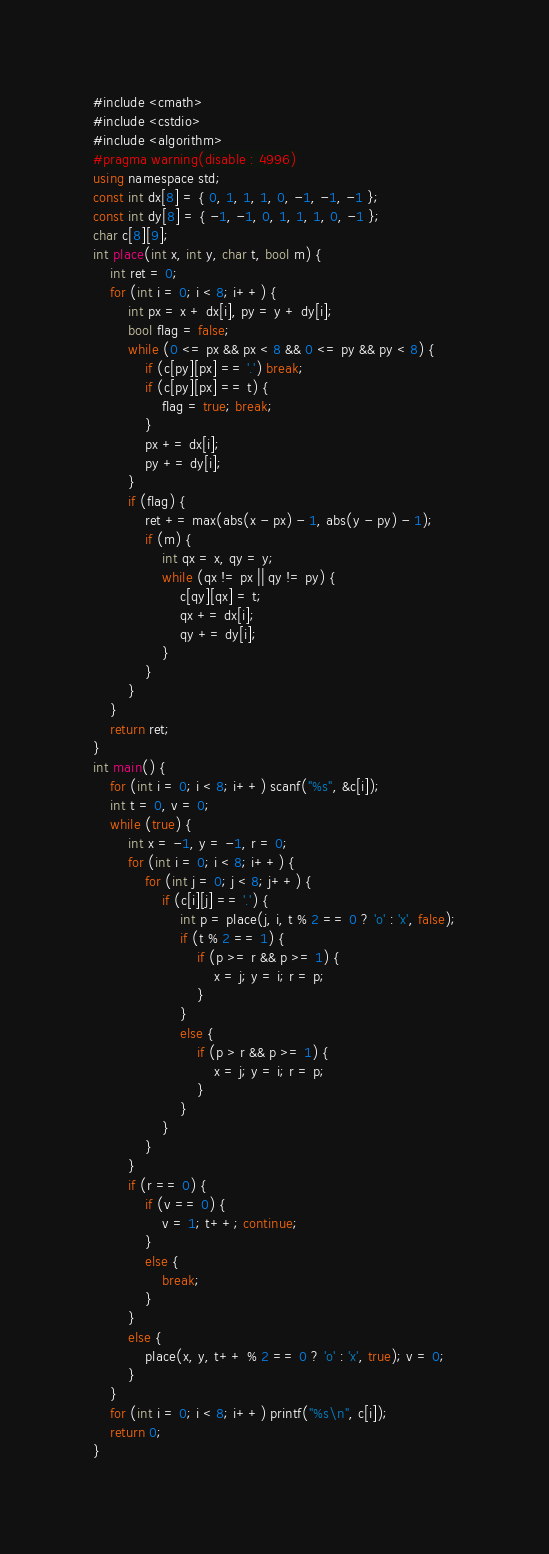Convert code to text. <code><loc_0><loc_0><loc_500><loc_500><_C#_>#include <cmath>
#include <cstdio>
#include <algorithm>
#pragma warning(disable : 4996)
using namespace std;
const int dx[8] = { 0, 1, 1, 1, 0, -1, -1, -1 };
const int dy[8] = { -1, -1, 0, 1, 1, 1, 0, -1 };
char c[8][9];
int place(int x, int y, char t, bool m) {
	int ret = 0;
	for (int i = 0; i < 8; i++) {
		int px = x + dx[i], py = y + dy[i];
		bool flag = false;
		while (0 <= px && px < 8 && 0 <= py && py < 8) {
			if (c[py][px] == '.') break;
			if (c[py][px] == t) {
				flag = true; break;
			}
			px += dx[i];
			py += dy[i];
		}
		if (flag) {
			ret += max(abs(x - px) - 1, abs(y - py) - 1);
			if (m) {
				int qx = x, qy = y;
				while (qx != px || qy != py) {
					c[qy][qx] = t;
					qx += dx[i];
					qy += dy[i];
				}
			}
		}
	}
	return ret;
}
int main() {
	for (int i = 0; i < 8; i++) scanf("%s", &c[i]);
	int t = 0, v = 0;
	while (true) {
		int x = -1, y = -1, r = 0;
		for (int i = 0; i < 8; i++) {
			for (int j = 0; j < 8; j++) {
				if (c[i][j] == '.') {
					int p = place(j, i, t % 2 == 0 ? 'o' : 'x', false);
					if (t % 2 == 1) {
						if (p >= r && p >= 1) {
							x = j; y = i; r = p;
						}
					}
					else {
						if (p > r && p >= 1) {
							x = j; y = i; r = p;
						}
					}
				}
			}
		}
		if (r == 0) {
			if (v == 0) {
				v = 1; t++; continue;
			}
			else {
				break;
			}
		}
		else {
			place(x, y, t++ % 2 == 0 ? 'o' : 'x', true); v = 0;
		}
	}
	for (int i = 0; i < 8; i++) printf("%s\n", c[i]);
	return 0;
}</code> 